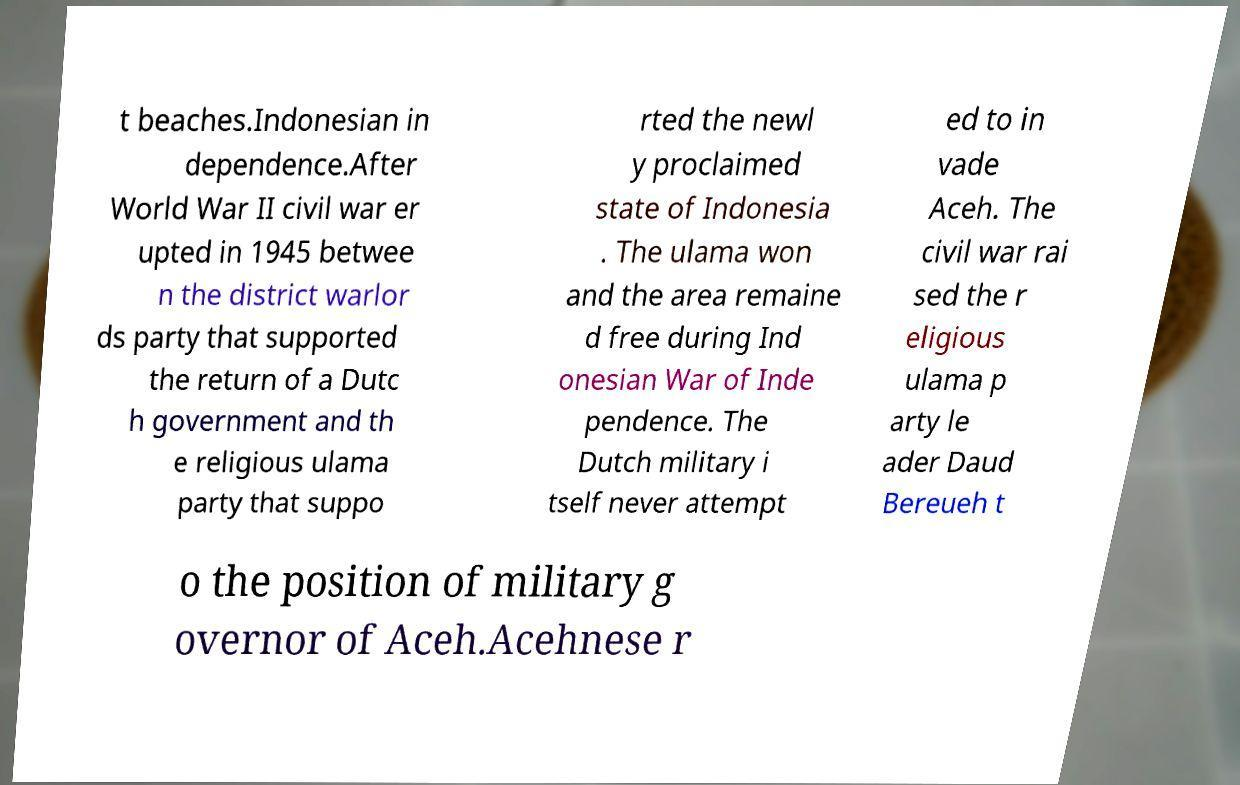Can you accurately transcribe the text from the provided image for me? t beaches.Indonesian in dependence.After World War II civil war er upted in 1945 betwee n the district warlor ds party that supported the return of a Dutc h government and th e religious ulama party that suppo rted the newl y proclaimed state of Indonesia . The ulama won and the area remaine d free during Ind onesian War of Inde pendence. The Dutch military i tself never attempt ed to in vade Aceh. The civil war rai sed the r eligious ulama p arty le ader Daud Bereueh t o the position of military g overnor of Aceh.Acehnese r 